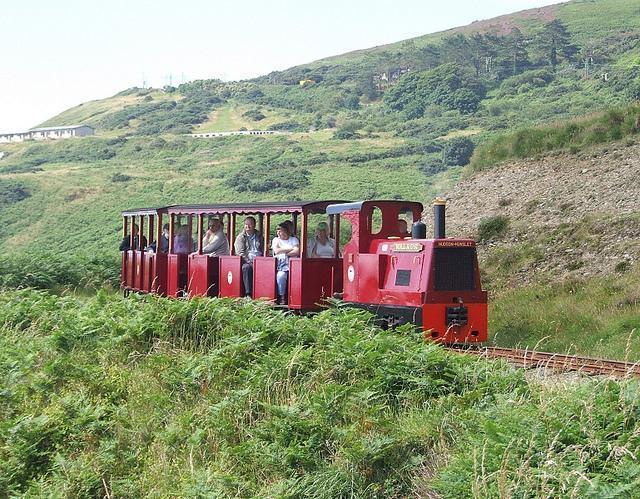How many cars are behind the train?
Give a very brief answer. 2. How many cars are traveling behind the train?
Give a very brief answer. 2. How many trains can be seen?
Give a very brief answer. 1. 